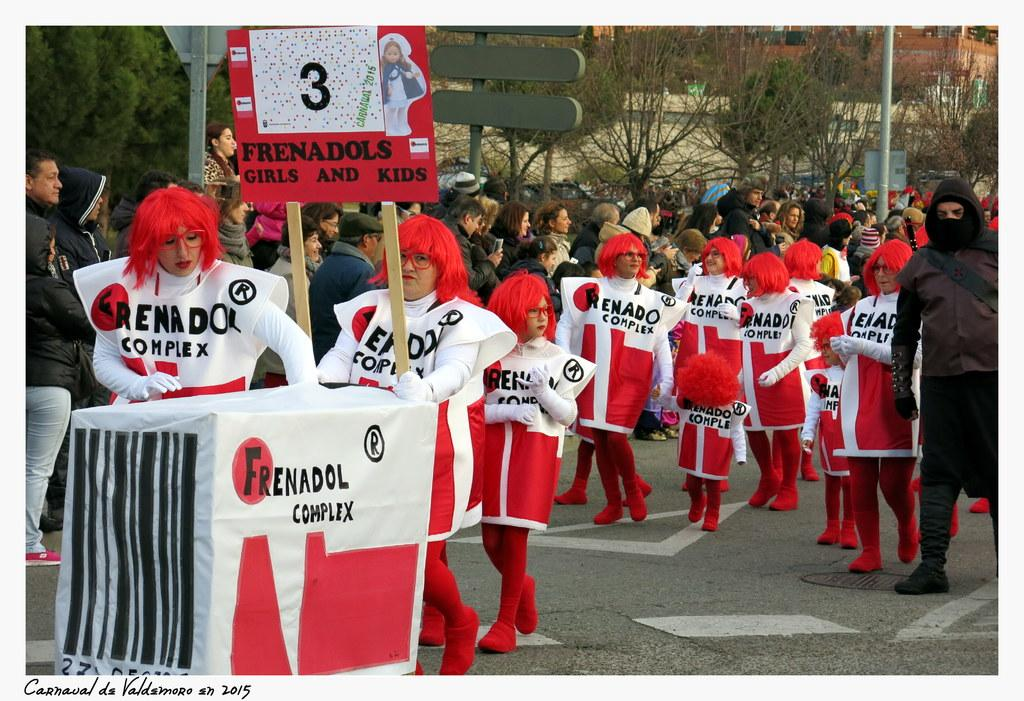<image>
Render a clear and concise summary of the photo. People in Frenadol Complex costumes march in a parade. 